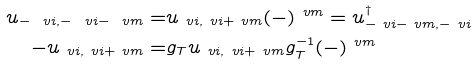Convert formula to latex. <formula><loc_0><loc_0><loc_500><loc_500>u _ { - \ v i , - \ v i - \ v m } = & u _ { \ v i , \ v i + \ v m } ( - ) ^ { \ v m } = u _ { - \ v i - \ v m , - \ v i } ^ { \dag } \\ - u _ { \ v i , \ v i + \ v m } = & g _ { T } u _ { \ v i , \ v i + \ v m } g _ { T } ^ { - 1 } ( - ) ^ { \ v m }</formula> 